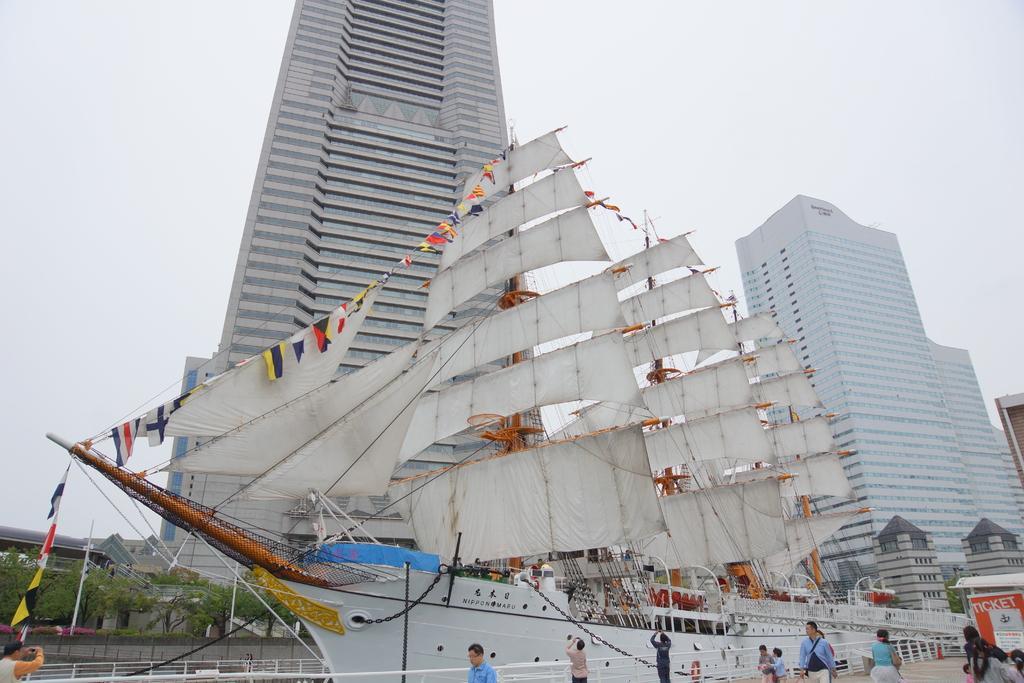In one or two sentences, can you explain what this image depicts? In this picture, we can see buildings, ship, and a few people, we can see fencing, posters, trees and the sky. 